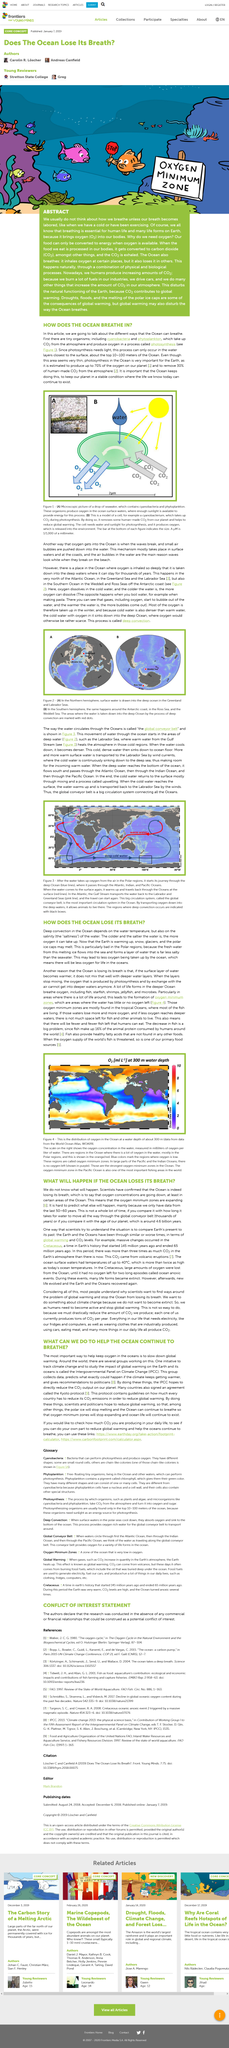Draw attention to some important aspects in this diagram. In figure 1, the drop of seawater is depicted to be approximately 2 micrometers in size. The scale on the right indicates the oxygen concentration in the water, as measured in milliliters of oxygen per liter of water. The global conveyor belt is used to describe the way in which water circulates. The main reason why waves appear white when they break on the beach is due to the presence of air bubbles. Photosynthesis cannot occur throughout the ocean, but it is only possible at the surface layer of 10-100 meters. 